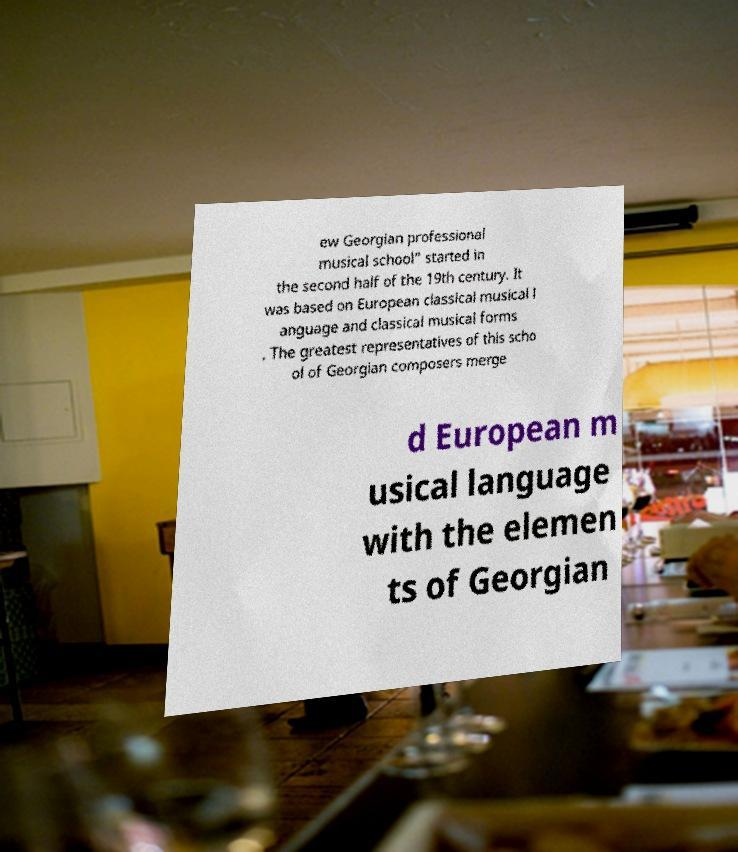Can you accurately transcribe the text from the provided image for me? ew Georgian professional musical school" started in the second half of the 19th century. It was based on European classical musical l anguage and classical musical forms . The greatest representatives of this scho ol of Georgian composers merge d European m usical language with the elemen ts of Georgian 